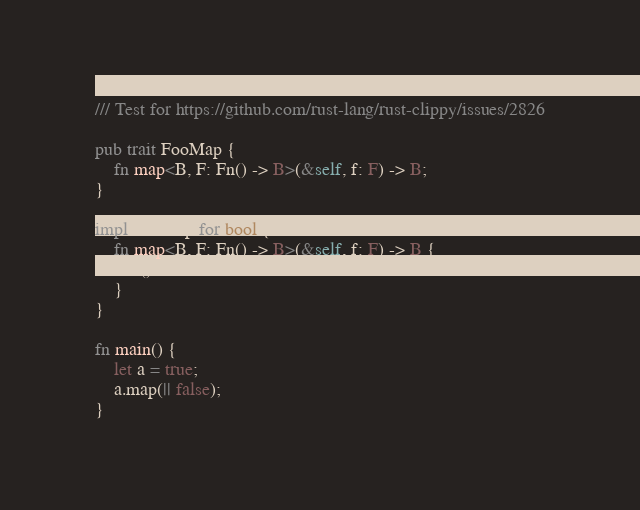<code> <loc_0><loc_0><loc_500><loc_500><_Rust_>/// Test for https://github.com/rust-lang/rust-clippy/issues/2826

pub trait FooMap {
    fn map<B, F: Fn() -> B>(&self, f: F) -> B;
}

impl FooMap for bool {
    fn map<B, F: Fn() -> B>(&self, f: F) -> B {
        f()
    }
}

fn main() {
    let a = true;
    a.map(|| false);
}
</code> 